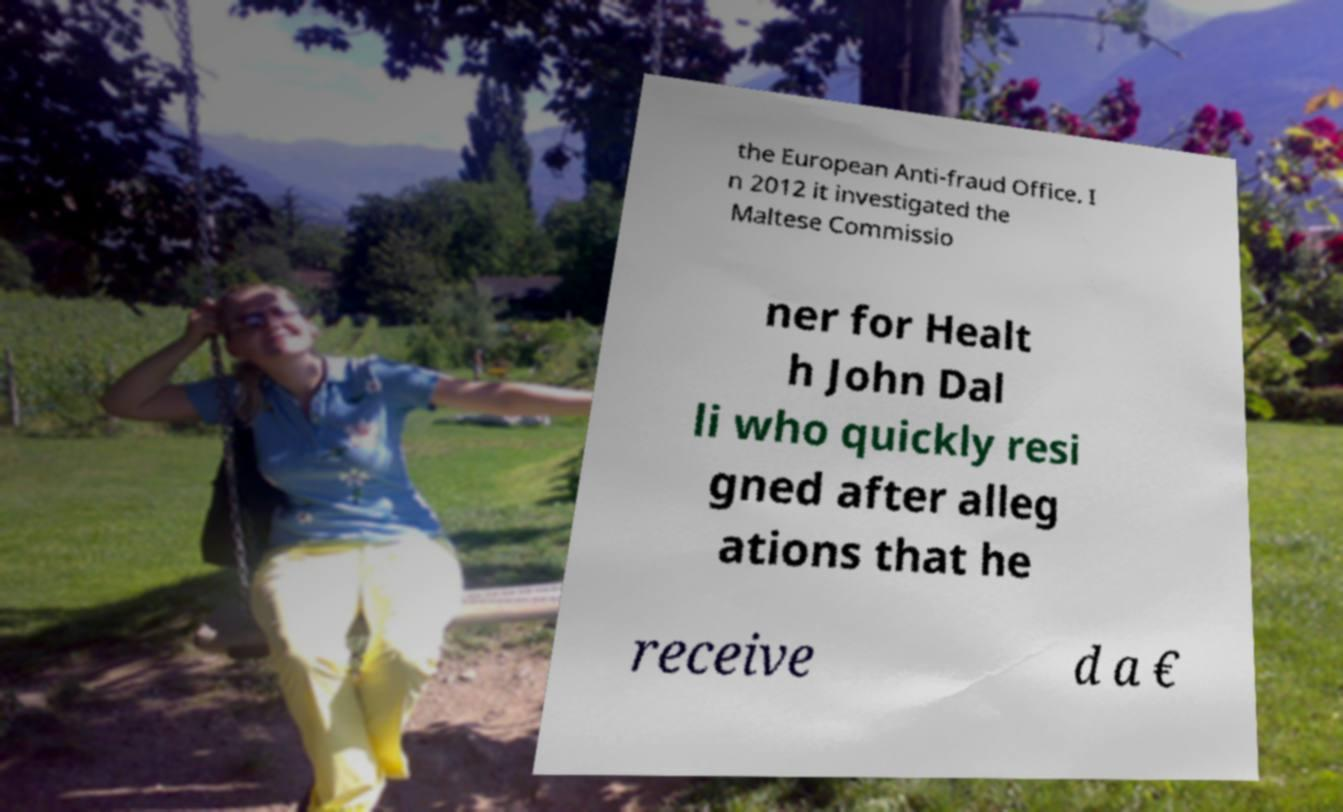There's text embedded in this image that I need extracted. Can you transcribe it verbatim? the European Anti-fraud Office. I n 2012 it investigated the Maltese Commissio ner for Healt h John Dal li who quickly resi gned after alleg ations that he receive d a € 